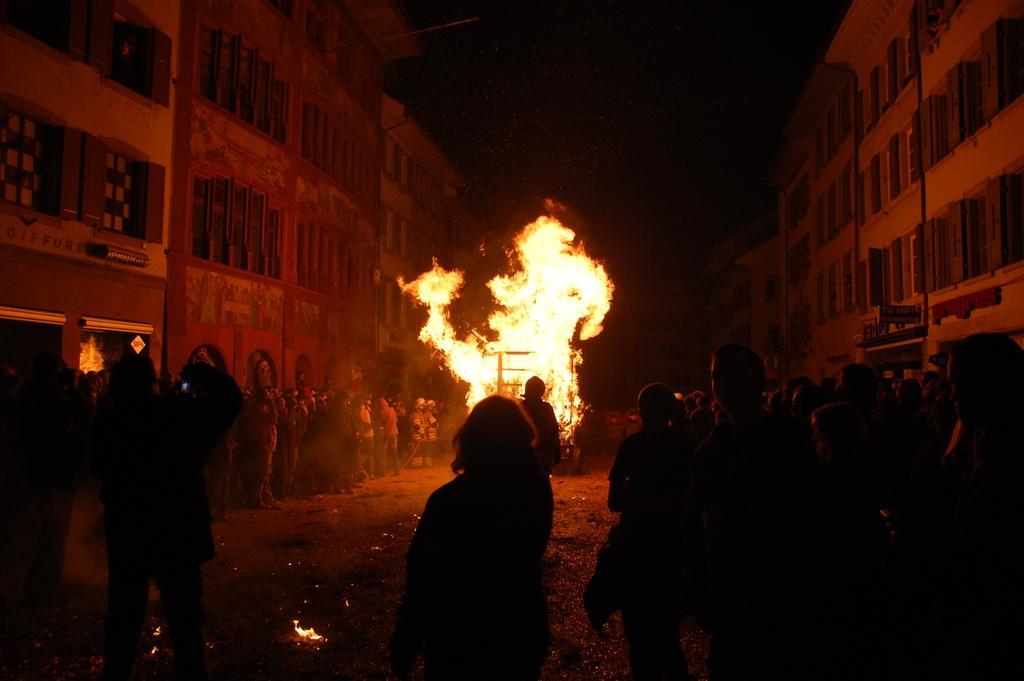What type of structures can be seen in the image? There are buildings in the image. What is happening in the image that involves fire? There is fire visible in the image. Are there any individuals present in the image? Yes, there are people present in the image. What type of test is being conducted in the image? There is no test being conducted in the image; it features buildings, fire, and people. What are the people talking about in the image? The conversation does not mention any specific topic that the people might be discussing in the image. 